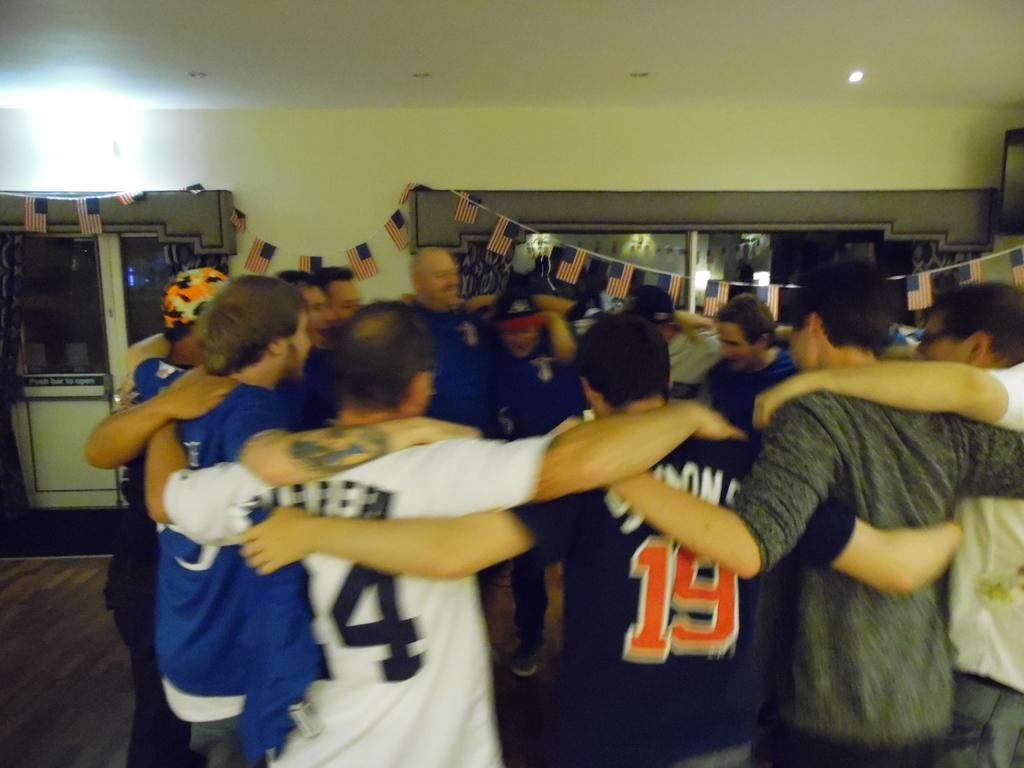What number is visible on the white shirt?
Offer a very short reply. 4. 